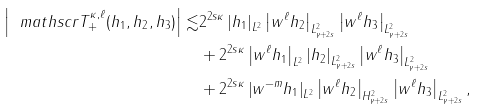Convert formula to latex. <formula><loc_0><loc_0><loc_500><loc_500>\left | \ m a t h s c r { T } _ { + } ^ { \kappa , \ell } ( h _ { 1 } , h _ { 2 } , h _ { 3 } ) \right | \lesssim & 2 ^ { 2 s \kappa } \left | h _ { 1 } \right | _ { L ^ { 2 } } \left | w ^ { \ell } h _ { 2 } \right | _ { L ^ { 2 } _ { \gamma + 2 s } } \left | w ^ { \ell } h _ { 3 } \right | _ { L ^ { 2 } _ { \gamma + 2 s } } \\ & + 2 ^ { 2 s \kappa } \left | w ^ { \ell } h _ { 1 } \right | _ { L ^ { 2 } } \left | h _ { 2 } \right | _ { L ^ { 2 } _ { \gamma + 2 s } } \left | w ^ { \ell } h _ { 3 } \right | _ { L ^ { 2 } _ { \gamma + 2 s } } \\ & + 2 ^ { 2 s \kappa } \left | w ^ { - m } h _ { 1 } \right | _ { L ^ { 2 } } \left | w ^ { \ell } h _ { 2 } \right | _ { H ^ { 2 } _ { \gamma + 2 s } } \left | w ^ { \ell } h _ { 3 } \right | _ { L ^ { 2 } _ { \gamma + 2 s } } ,</formula> 